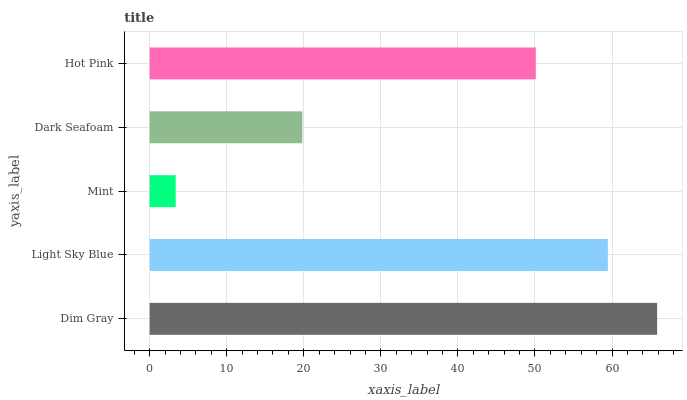Is Mint the minimum?
Answer yes or no. Yes. Is Dim Gray the maximum?
Answer yes or no. Yes. Is Light Sky Blue the minimum?
Answer yes or no. No. Is Light Sky Blue the maximum?
Answer yes or no. No. Is Dim Gray greater than Light Sky Blue?
Answer yes or no. Yes. Is Light Sky Blue less than Dim Gray?
Answer yes or no. Yes. Is Light Sky Blue greater than Dim Gray?
Answer yes or no. No. Is Dim Gray less than Light Sky Blue?
Answer yes or no. No. Is Hot Pink the high median?
Answer yes or no. Yes. Is Hot Pink the low median?
Answer yes or no. Yes. Is Dark Seafoam the high median?
Answer yes or no. No. Is Dark Seafoam the low median?
Answer yes or no. No. 